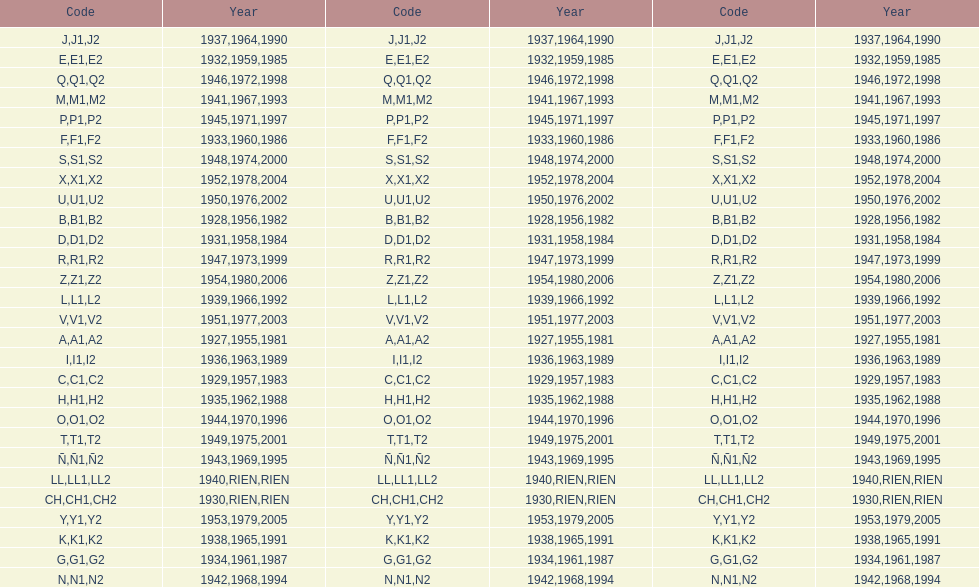List each code not associated to a year. CH1, CH2, LL1, LL2. 